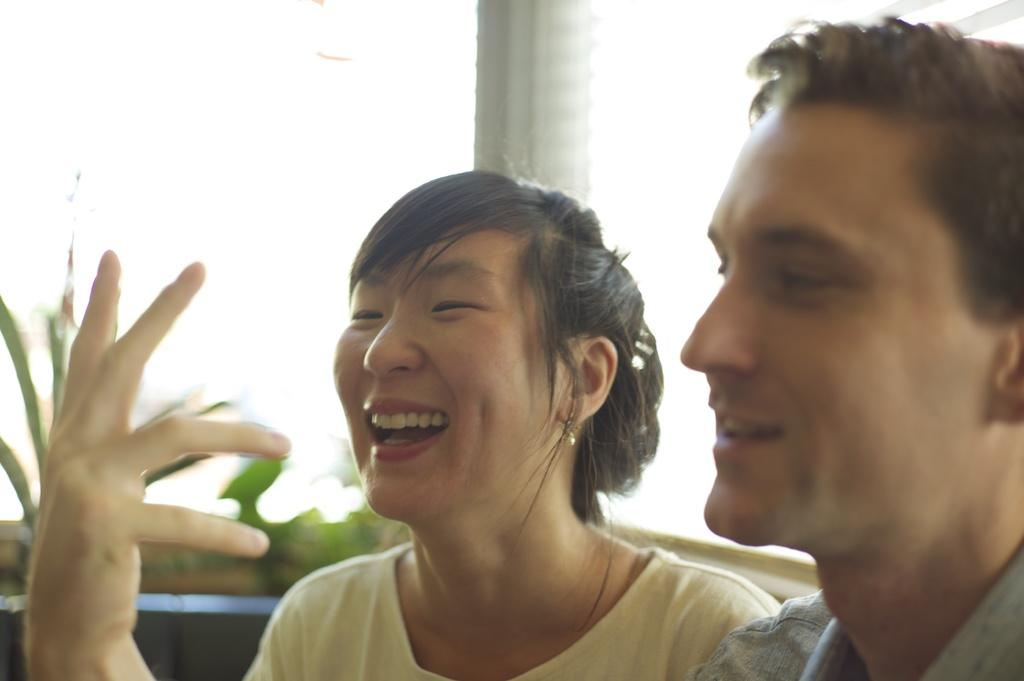How many people are in the image? There are two persons in the image. What can be seen in the background of the image? There is a pillar in the background of the image. How would you describe the background of the image? The background of the image is blurred. What type of ticket is the person holding in the image? There is no ticket visible in the image. Can you see a train in the background of the image? There is no train present in the image. 